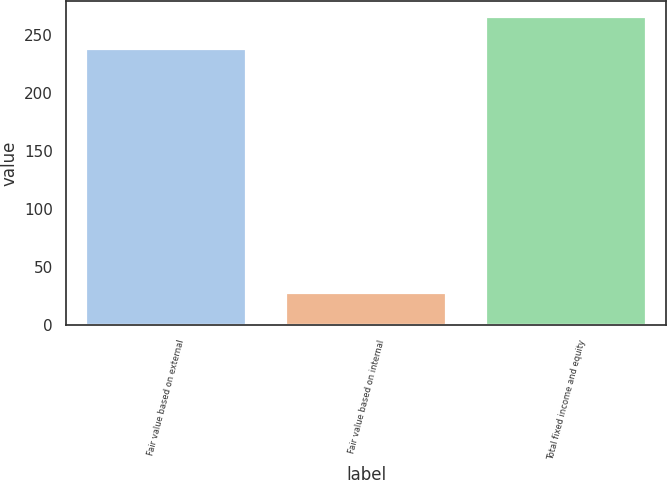Convert chart to OTSL. <chart><loc_0><loc_0><loc_500><loc_500><bar_chart><fcel>Fair value based on external<fcel>Fair value based on internal<fcel>Total fixed income and equity<nl><fcel>238<fcel>28<fcel>266<nl></chart> 